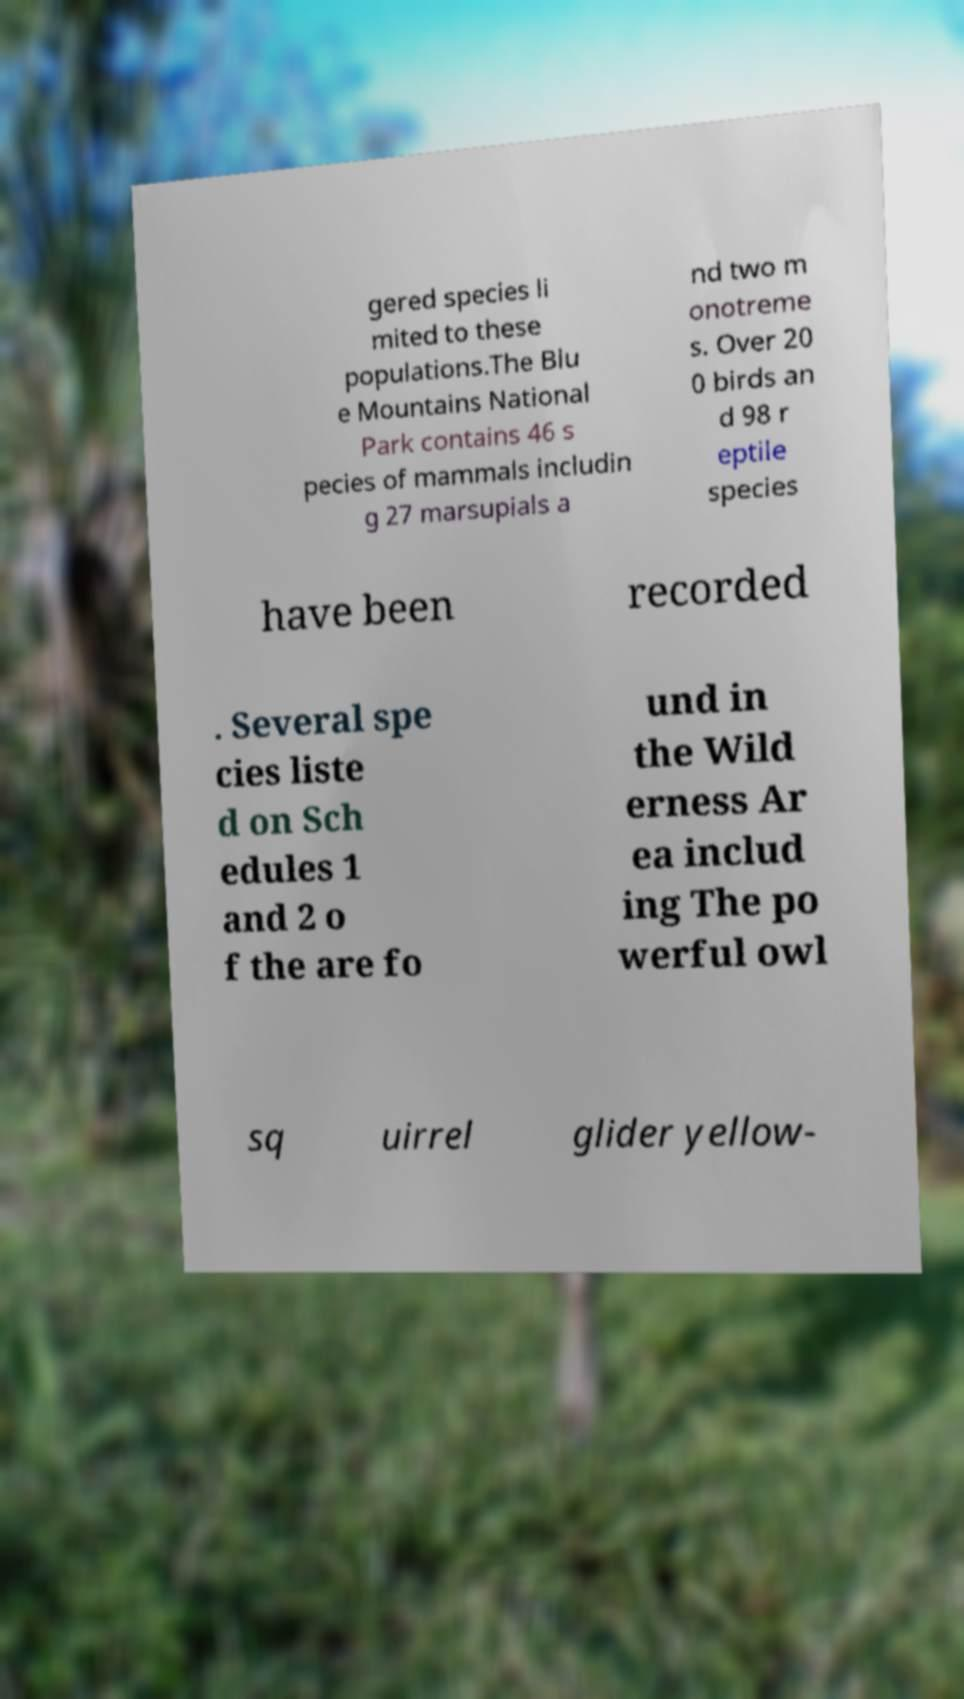I need the written content from this picture converted into text. Can you do that? gered species li mited to these populations.The Blu e Mountains National Park contains 46 s pecies of mammals includin g 27 marsupials a nd two m onotreme s. Over 20 0 birds an d 98 r eptile species have been recorded . Several spe cies liste d on Sch edules 1 and 2 o f the are fo und in the Wild erness Ar ea includ ing The po werful owl sq uirrel glider yellow- 